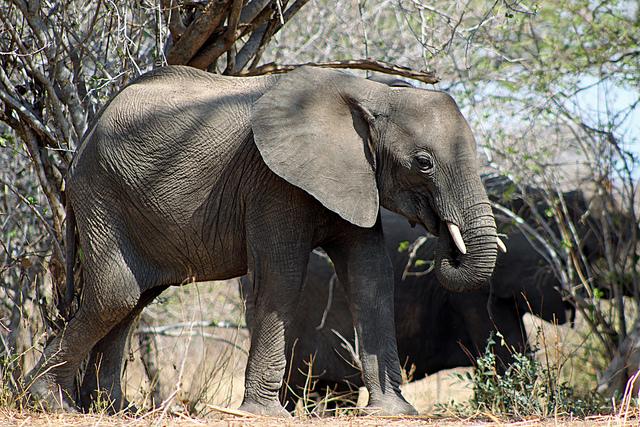Is the elephant's eye open?
Quick response, please. Yes. What is the elephant doing?
Concise answer only. Eating. Are these elephants in the wild?
Keep it brief. Yes. 